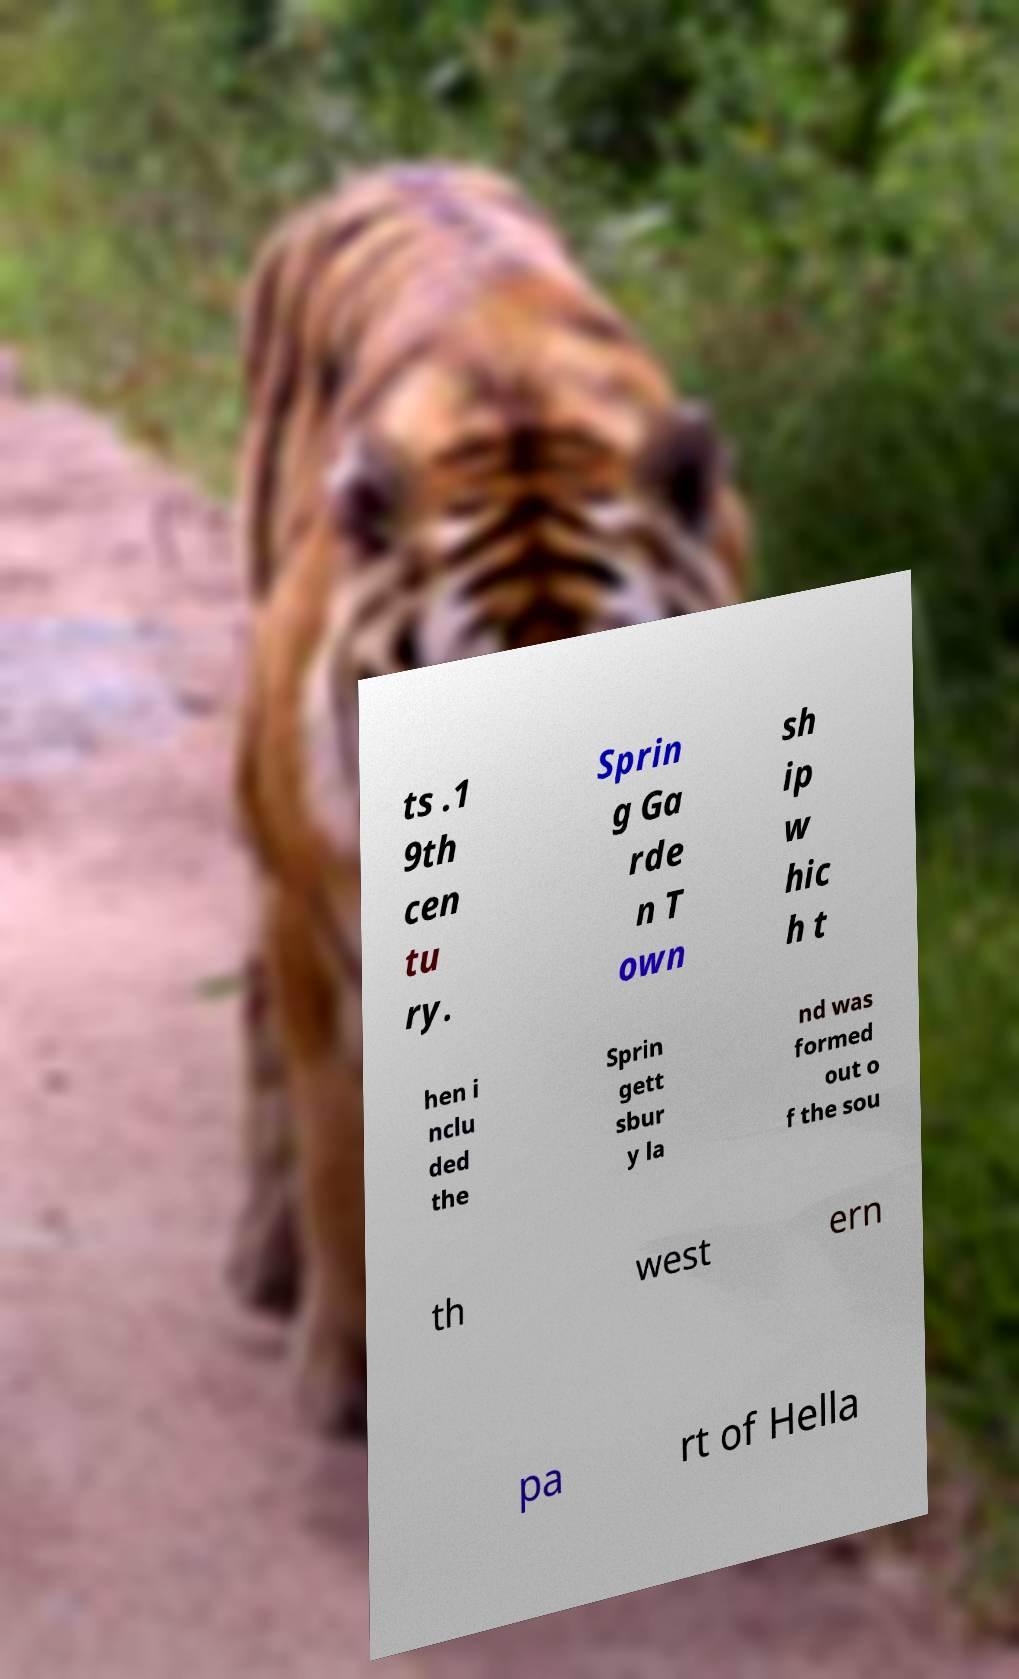I need the written content from this picture converted into text. Can you do that? ts .1 9th cen tu ry. Sprin g Ga rde n T own sh ip w hic h t hen i nclu ded the Sprin gett sbur y la nd was formed out o f the sou th west ern pa rt of Hella 